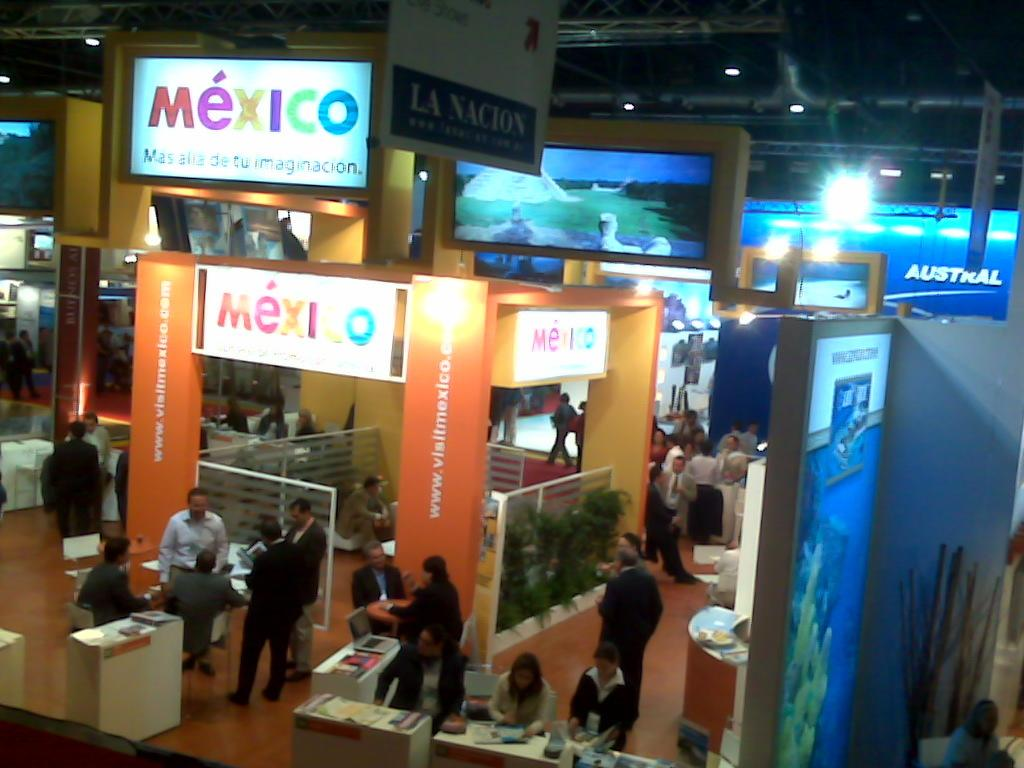<image>
Render a clear and concise summary of the photo. A group of people are near the Mexico exhibit at the travel convention. 